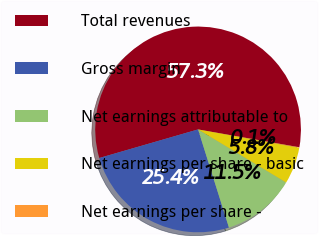<chart> <loc_0><loc_0><loc_500><loc_500><pie_chart><fcel>Total revenues<fcel>Gross margin<fcel>Net earnings attributable to<fcel>Net earnings per share - basic<fcel>Net earnings per share -<nl><fcel>57.26%<fcel>25.37%<fcel>11.51%<fcel>5.79%<fcel>0.07%<nl></chart> 